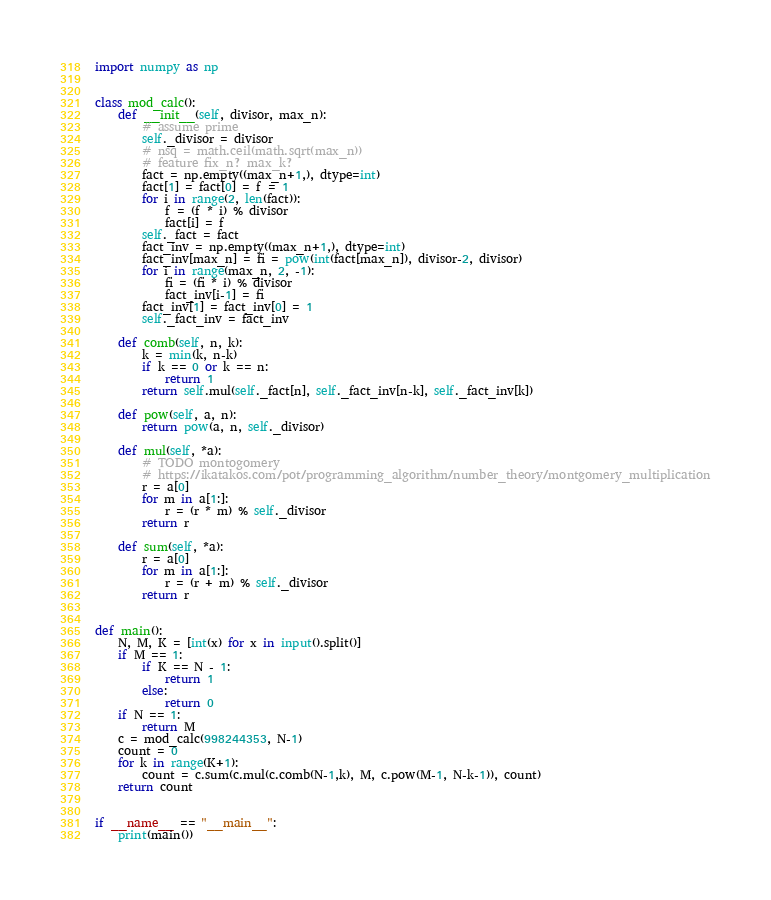<code> <loc_0><loc_0><loc_500><loc_500><_Python_>import numpy as np


class mod_calc():
    def __init__(self, divisor, max_n):
        # assume prime
        self._divisor = divisor
        # nsq = math.ceil(math.sqrt(max_n))
        # feature fix_n? max_k?
        fact = np.empty((max_n+1,), dtype=int)
        fact[1] = fact[0] = f = 1
        for i in range(2, len(fact)):
            f = (f * i) % divisor
            fact[i] = f
        self._fact = fact
        fact_inv = np.empty((max_n+1,), dtype=int)
        fact_inv[max_n] = fi = pow(int(fact[max_n]), divisor-2, divisor)
        for i in range(max_n, 2, -1):
            fi = (fi * i) % divisor
            fact_inv[i-1] = fi
        fact_inv[1] = fact_inv[0] = 1
        self._fact_inv = fact_inv

    def comb(self, n, k):
        k = min(k, n-k)
        if k == 0 or k == n:
            return 1
        return self.mul(self._fact[n], self._fact_inv[n-k], self._fact_inv[k])

    def pow(self, a, n):
        return pow(a, n, self._divisor)

    def mul(self, *a):
        # TODO montogomery
        # https://ikatakos.com/pot/programming_algorithm/number_theory/montgomery_multiplication
        r = a[0]
        for m in a[1:]:
            r = (r * m) % self._divisor
        return r

    def sum(self, *a):
        r = a[0]
        for m in a[1:]:
            r = (r + m) % self._divisor
        return r


def main():
    N, M, K = [int(x) for x in input().split()]
    if M == 1:
        if K == N - 1:
            return 1
        else:
            return 0
    if N == 1:
        return M
    c = mod_calc(998244353, N-1)
    count = 0
    for k in range(K+1):
        count = c.sum(c.mul(c.comb(N-1,k), M, c.pow(M-1, N-k-1)), count)
    return count


if __name__ == "__main__":
    print(main())
</code> 